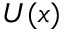<formula> <loc_0><loc_0><loc_500><loc_500>U ( x )</formula> 